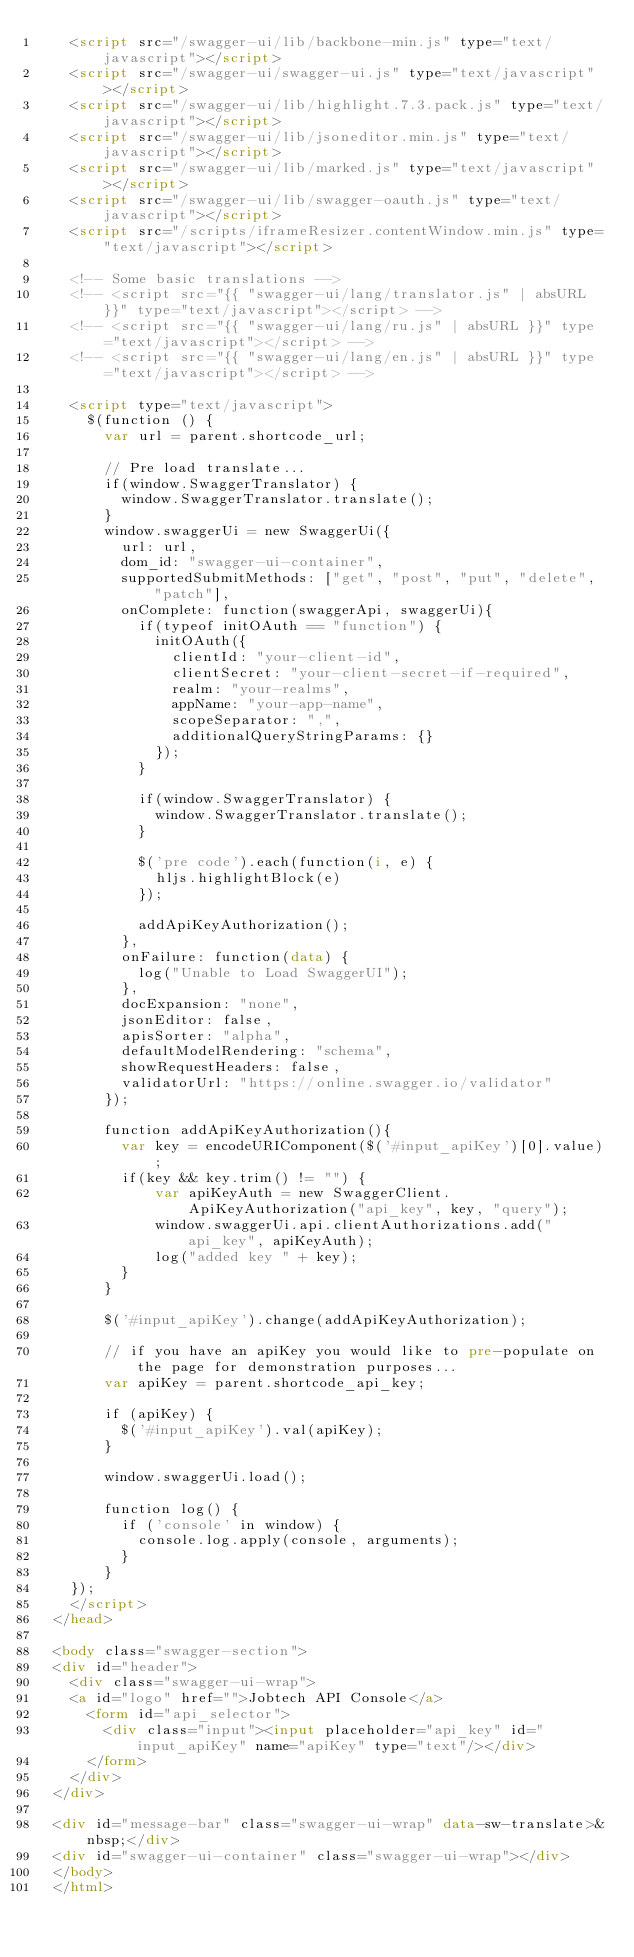Convert code to text. <code><loc_0><loc_0><loc_500><loc_500><_HTML_>    <script src="/swagger-ui/lib/backbone-min.js" type="text/javascript"></script>
    <script src="/swagger-ui/swagger-ui.js" type="text/javascript"></script>
    <script src="/swagger-ui/lib/highlight.7.3.pack.js" type="text/javascript"></script>
    <script src="/swagger-ui/lib/jsoneditor.min.js" type="text/javascript"></script>
    <script src="/swagger-ui/lib/marked.js" type="text/javascript"></script>
    <script src="/swagger-ui/lib/swagger-oauth.js" type="text/javascript"></script>
    <script src="/scripts/iframeResizer.contentWindow.min.js" type="text/javascript"></script>

    <!-- Some basic translations -->
    <!-- <script src="{{ "swagger-ui/lang/translator.js" | absURL }}" type="text/javascript"></script> -->
    <!-- <script src="{{ "swagger-ui/lang/ru.js" | absURL }}" type="text/javascript"></script> -->
    <!-- <script src="{{ "swagger-ui/lang/en.js" | absURL }}" type="text/javascript"></script> -->

    <script type="text/javascript">
      $(function () {
        var url = parent.shortcode_url;

        // Pre load translate...
        if(window.SwaggerTranslator) {
          window.SwaggerTranslator.translate();
        }
        window.swaggerUi = new SwaggerUi({
          url: url,
          dom_id: "swagger-ui-container",
          supportedSubmitMethods: ["get", "post", "put", "delete", "patch"],
          onComplete: function(swaggerApi, swaggerUi){
            if(typeof initOAuth == "function") {
              initOAuth({
                clientId: "your-client-id",
                clientSecret: "your-client-secret-if-required",
                realm: "your-realms",
                appName: "your-app-name",
                scopeSeparator: ",",
                additionalQueryStringParams: {}
              });
            }

            if(window.SwaggerTranslator) {
              window.SwaggerTranslator.translate();
            }

            $('pre code').each(function(i, e) {
              hljs.highlightBlock(e)
            });

            addApiKeyAuthorization();
          },
          onFailure: function(data) {
            log("Unable to Load SwaggerUI");
          },
          docExpansion: "none",
          jsonEditor: false,
          apisSorter: "alpha",
          defaultModelRendering: "schema",
          showRequestHeaders: false,
          validatorUrl: "https://online.swagger.io/validator"
        });

        function addApiKeyAuthorization(){
          var key = encodeURIComponent($('#input_apiKey')[0].value);
          if(key && key.trim() != "") {
              var apiKeyAuth = new SwaggerClient.ApiKeyAuthorization("api_key", key, "query");
              window.swaggerUi.api.clientAuthorizations.add("api_key", apiKeyAuth);
              log("added key " + key);
          }
        }

        $('#input_apiKey').change(addApiKeyAuthorization);

        // if you have an apiKey you would like to pre-populate on the page for demonstration purposes...
        var apiKey = parent.shortcode_api_key;

        if (apiKey) {
          $('#input_apiKey').val(apiKey);
        }

        window.swaggerUi.load();

        function log() {
          if ('console' in window) {
            console.log.apply(console, arguments);
          }
        }
    });
    </script>
  </head>

  <body class="swagger-section">
  <div id="header">
    <div class="swagger-ui-wrap">
    <a id="logo" href="">Jobtech API Console</a>
      <form id="api_selector">
        <div class="input"><input placeholder="api_key" id="input_apiKey" name="apiKey" type="text"/></div>
      </form>
    </div>
  </div>

  <div id="message-bar" class="swagger-ui-wrap" data-sw-translate>&nbsp;</div>
  <div id="swagger-ui-container" class="swagger-ui-wrap"></div>
  </body>
  </html>
</code> 